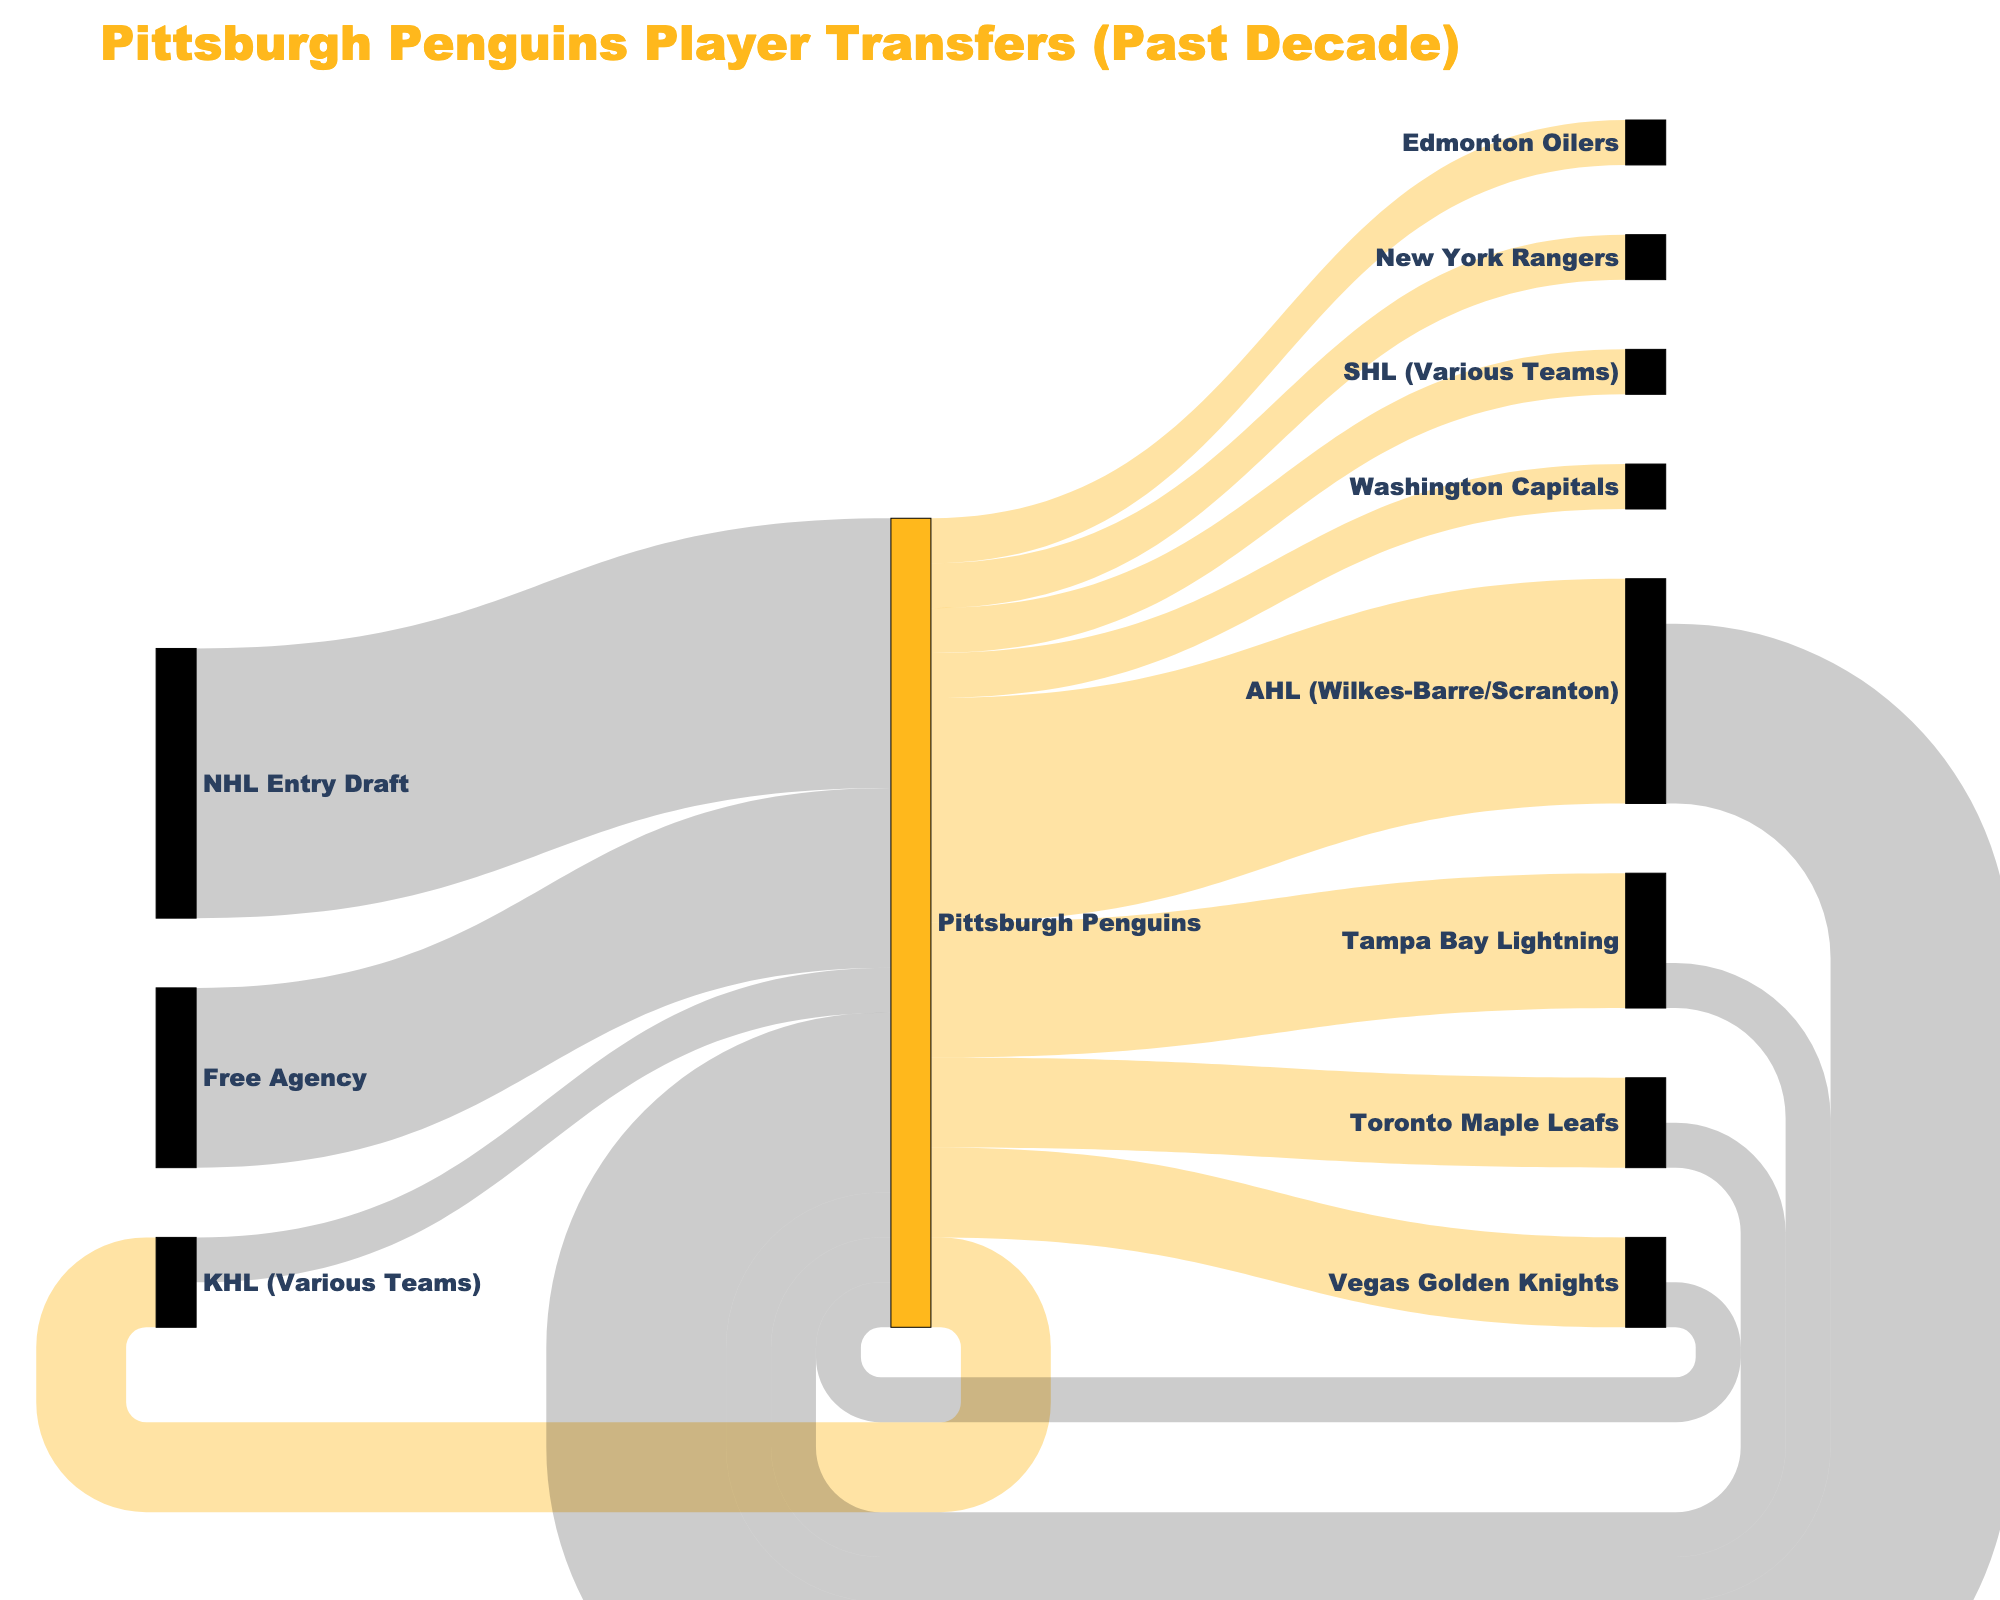What is the title of the Sankey diagram? The title is usually located at the top of the chart and is clearly marked in a larger font size.
Answer: Pittsburgh Penguins Player Transfers (Past Decade) How many players were transferred from the Pittsburgh Penguins to the Tampa Bay Lightning? Look for the link between the Pittsburgh Penguins and the Tampa Bay Lightning and check the value labeled there.
Answer: 3 Which team received the most players from the Pittsburgh Penguins? Identify the source node labeled "Pittsburgh Penguins" and trace the outgoing links to find the one with the highest value.
Answer: AHL (Wilkes-Barre/Scranton) How many players did the Pittsburgh Penguins acquire through the NHL Entry Draft? Find the link where NHL Entry Draft is the source and Pittsburgh Penguins is the target, and note the value.
Answer: 6 How many players went from the Pittsburgh Penguins to various leagues outside the NHL, such as KHL and SHL? Sum the values of the links from Pittsburgh Penguins to KHL (Various Teams) and SHL (Various Teams).
Answer: 3 Compare the number of players transferred to the AHL and through Free Agency to the Pittsburgh Penguins. Which source provided more players? Identify the values of the links where AHL (Wilkes-Barre/Scranton) and Free Agency are the sources to Pittsburgh Penguins, and compare them.
Answer: AHL (Wilkes-Barre/Scranton) What is the total number of players that moved to other NHL teams from the Pittsburgh Penguins? Sum the values of the links from the Pittsburgh Penguins to various NHL teams, including Tampa Bay Lightning, Toronto Maple Leafs, Vegas Golden Knights, Washington Capitals, Edmonton Oilers, and New York Rangers.
Answer: 10 Which direction shows more player movement, from Pittsburgh Penguins to other teams/leagues or from other sources to Pittsburgh Penguins? Compare the total sum of values for outgoing links from Pittsburgh Penguins to the total sum of values for incoming links to Pittsburgh Penguins. This involves adding all outgoing values and all incoming values separately.
Answer: From other sources to Pittsburgh Penguins How many players moved between the Pittsburgh Penguins and other major NHL teams (Tampa Bay, Toronto, Vegas, Washington, Edmonton, New York Rangers) in total? Count both outgoing and incoming players between Pittsburgh Penguins and these NHL teams by summing the corresponding link values.
Answer: 11 Which source provided the second-largest number of players to the Pittsburgh Penguins? Identify the values of incoming links to the Pittsburgh Penguins and look for the highest value that is not the largest value.
Answer: Free Agency 